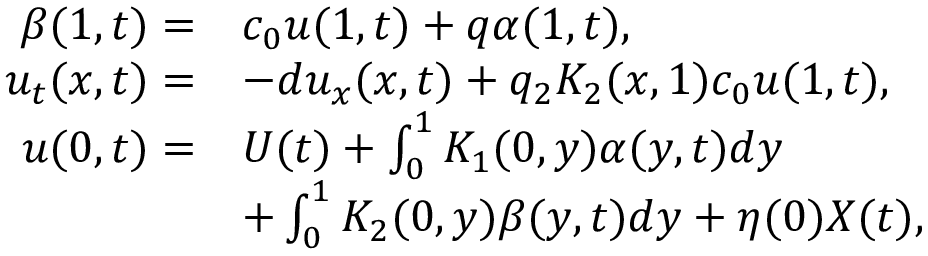<formula> <loc_0><loc_0><loc_500><loc_500>\begin{array} { r l } { \beta ( 1 , t ) = } & { c _ { 0 } u ( 1 , t ) + q \alpha ( 1 , t ) , } \\ { { u _ { t } } ( x , t ) = } & { - d { u _ { x } } ( x , t ) + q _ { 2 } K _ { 2 } ( x , 1 ) c _ { 0 } u ( 1 , t ) , } \\ { u ( 0 , t ) = } & { U ( t ) + \int _ { 0 } ^ { 1 } K _ { 1 } ( 0 , y ) \alpha ( y , t ) d y } \\ & { + \int _ { 0 } ^ { 1 } K _ { 2 } ( 0 , y ) \beta ( y , t ) d y + \eta ( 0 ) { X } ( t ) , } \end{array}</formula> 